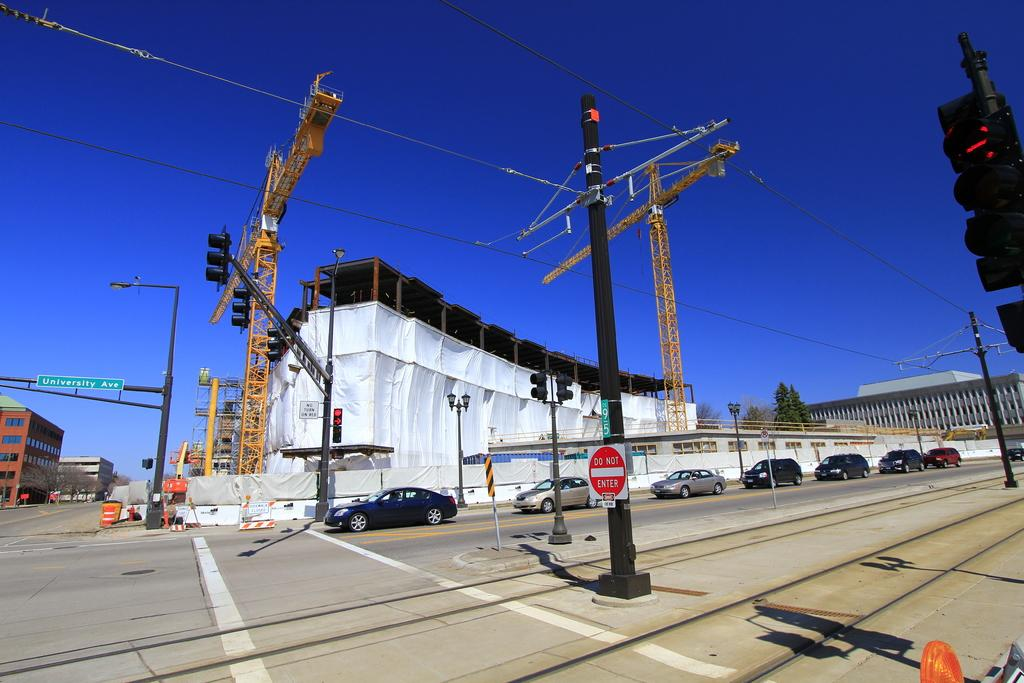What can be seen in the foreground of the image? In the foreground of the image, there are vehicles, poles, and wires. What is visible in the background of the image? In the background of the image, there are buildings, trees, and the sky. What type of structures are present in the background? The structures in the background are buildings. What type of vegetation is present in the background? The vegetation in the background is trees. How many pizzas are being cooked on the stove in the image? There is no stove or pizzas present in the image. What type of connection can be seen between the poles in the image? The image does not show any specific connection between the poles; it only shows the presence of poles and wires. 